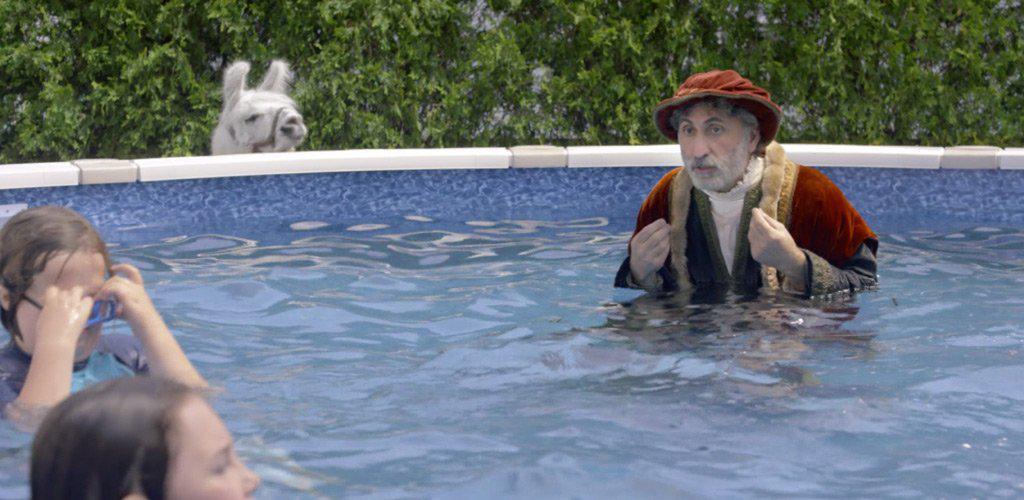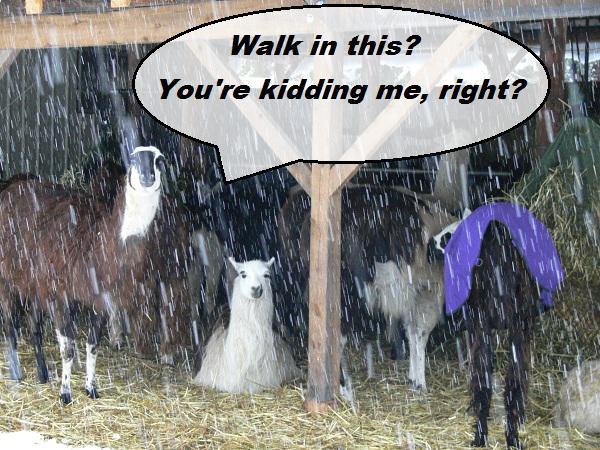The first image is the image on the left, the second image is the image on the right. Analyze the images presented: Is the assertion "The left image contains no more than one llama." valid? Answer yes or no. Yes. The first image is the image on the left, the second image is the image on the right. Given the left and right images, does the statement "A forward-turned llama is behind a blue swimming pool in the lefthand image." hold true? Answer yes or no. Yes. 